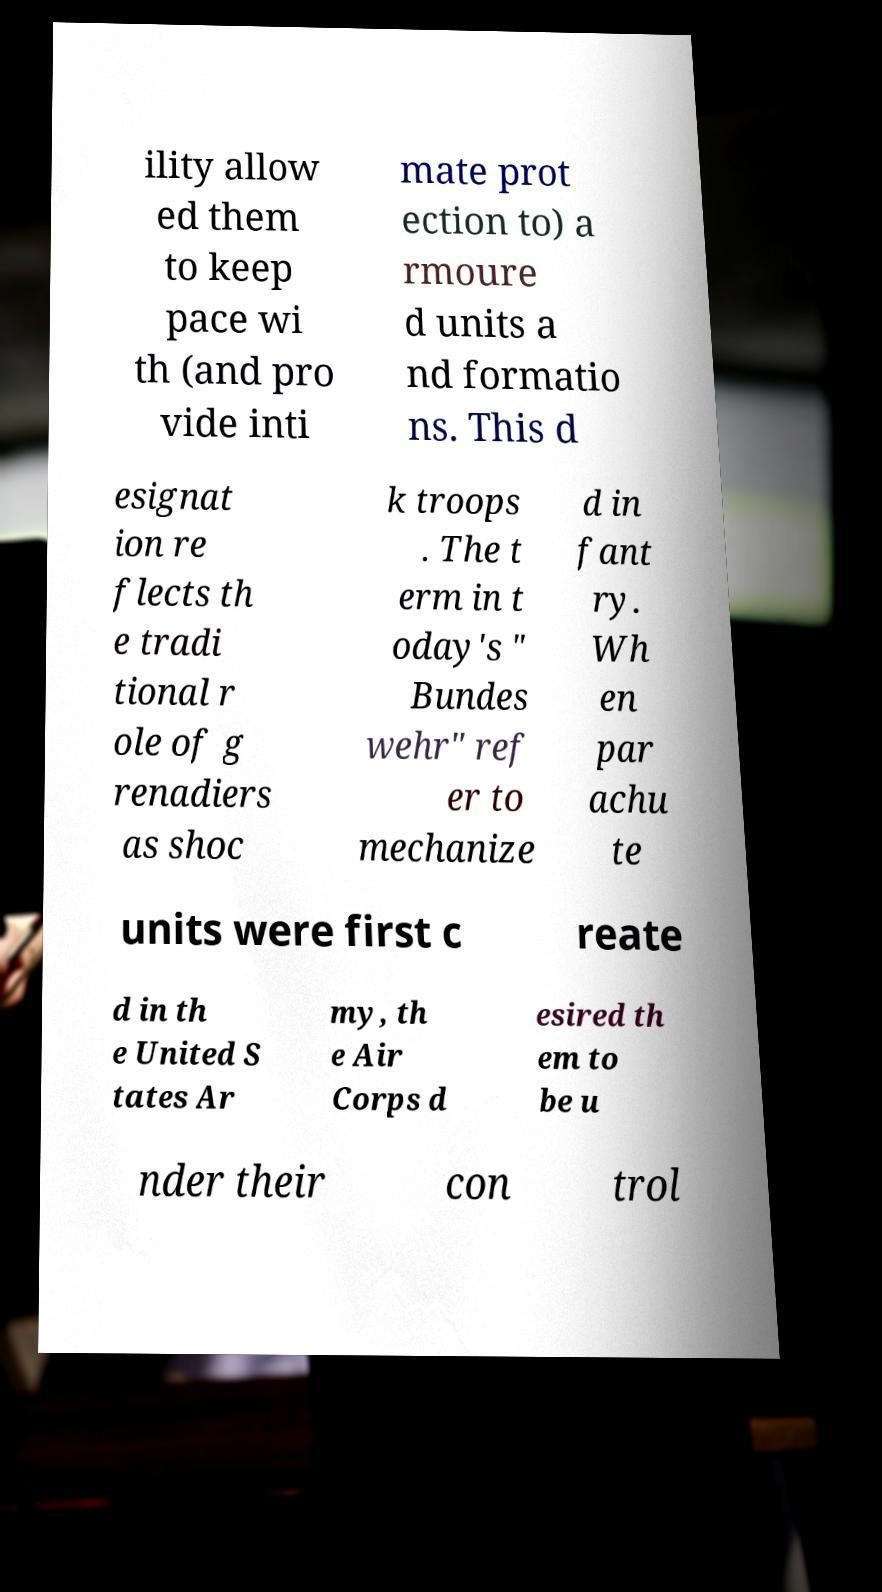There's text embedded in this image that I need extracted. Can you transcribe it verbatim? ility allow ed them to keep pace wi th (and pro vide inti mate prot ection to) a rmoure d units a nd formatio ns. This d esignat ion re flects th e tradi tional r ole of g renadiers as shoc k troops . The t erm in t oday's " Bundes wehr" ref er to mechanize d in fant ry. Wh en par achu te units were first c reate d in th e United S tates Ar my, th e Air Corps d esired th em to be u nder their con trol 